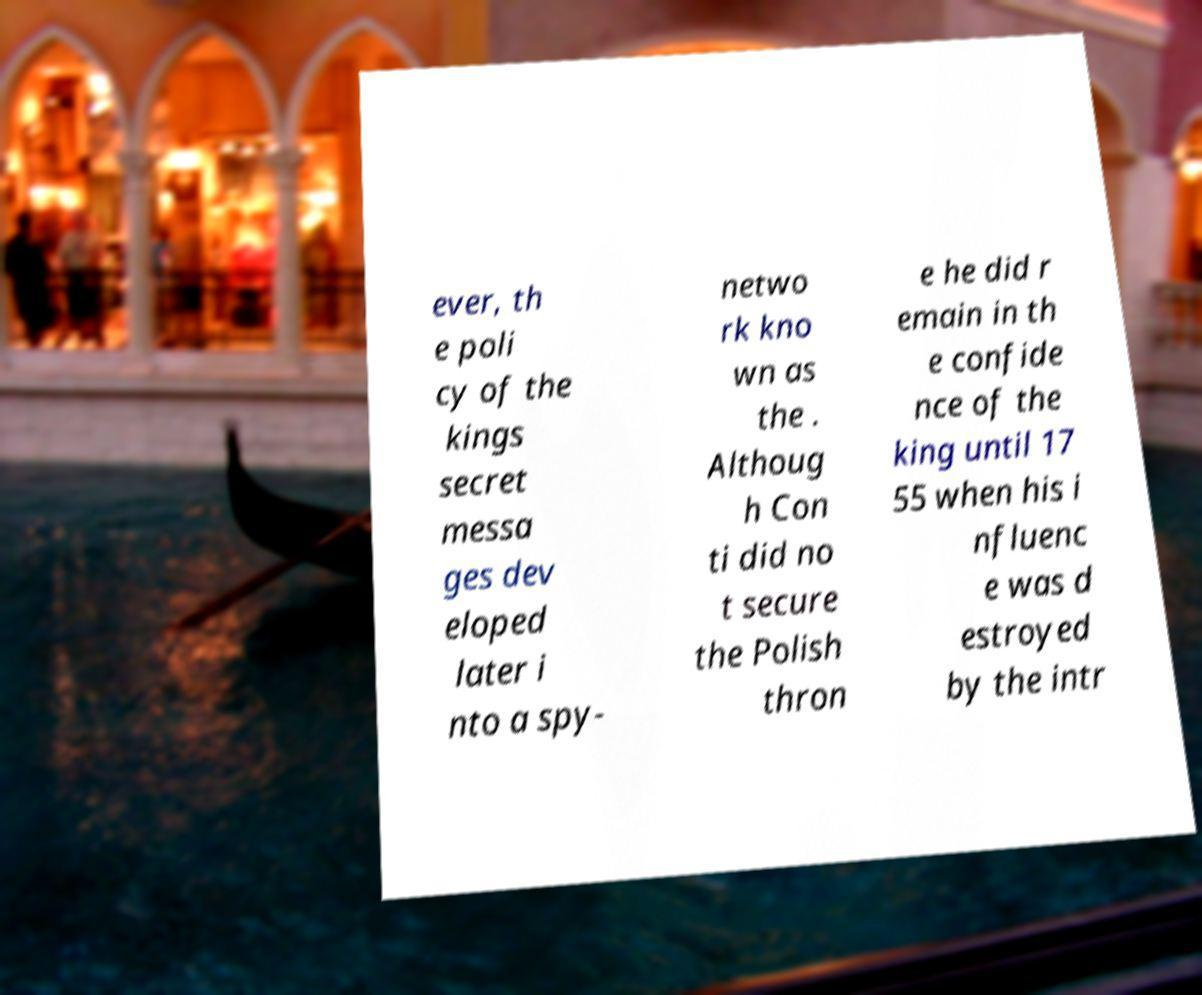Can you read and provide the text displayed in the image?This photo seems to have some interesting text. Can you extract and type it out for me? ever, th e poli cy of the kings secret messa ges dev eloped later i nto a spy- netwo rk kno wn as the . Althoug h Con ti did no t secure the Polish thron e he did r emain in th e confide nce of the king until 17 55 when his i nfluenc e was d estroyed by the intr 